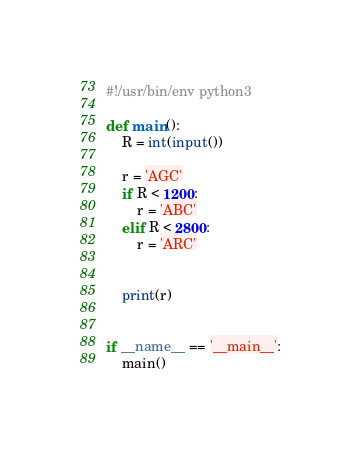<code> <loc_0><loc_0><loc_500><loc_500><_Python_>#!/usr/bin/env python3

def main():
    R = int(input())

    r = 'AGC'
    if R < 1200:
        r = 'ABC'
    elif R < 2800:
        r = 'ARC'


    print(r)


if __name__ == '__main__':
    main()

</code> 